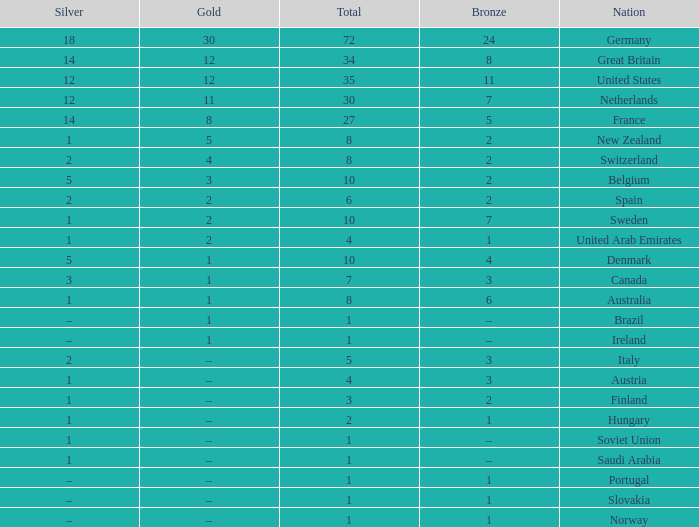What is Gold, when Silver is 5, and when Nation is Belgium? 3.0. 